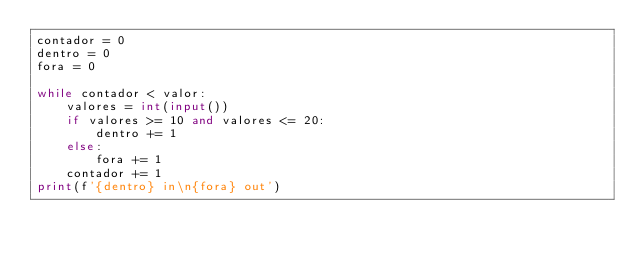<code> <loc_0><loc_0><loc_500><loc_500><_Python_>contador = 0
dentro = 0
fora = 0

while contador < valor:
    valores = int(input())
    if valores >= 10 and valores <= 20:
        dentro += 1
    else:
        fora += 1
    contador += 1
print(f'{dentro} in\n{fora} out')
</code> 